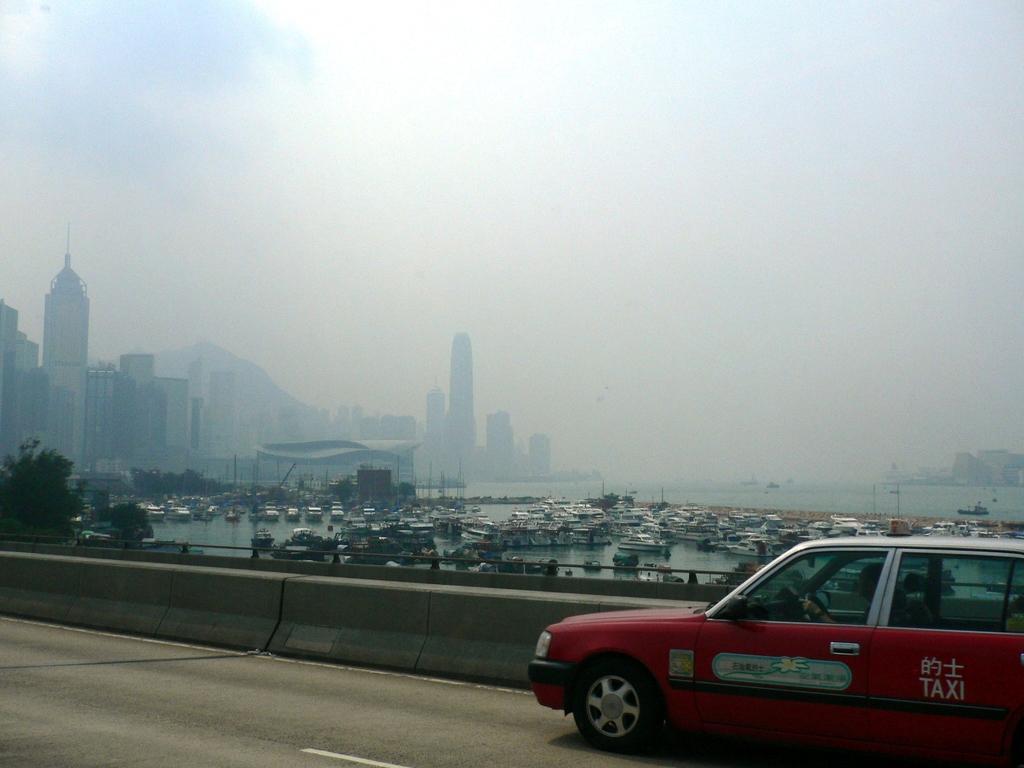Could you give a brief overview of what you see in this image? In this image I can see the car on the road. It is in red color. To the side there is a railing. In the back I can see many boats and the water. To the left there are trees. In the background I can see many buildings and the sky. 